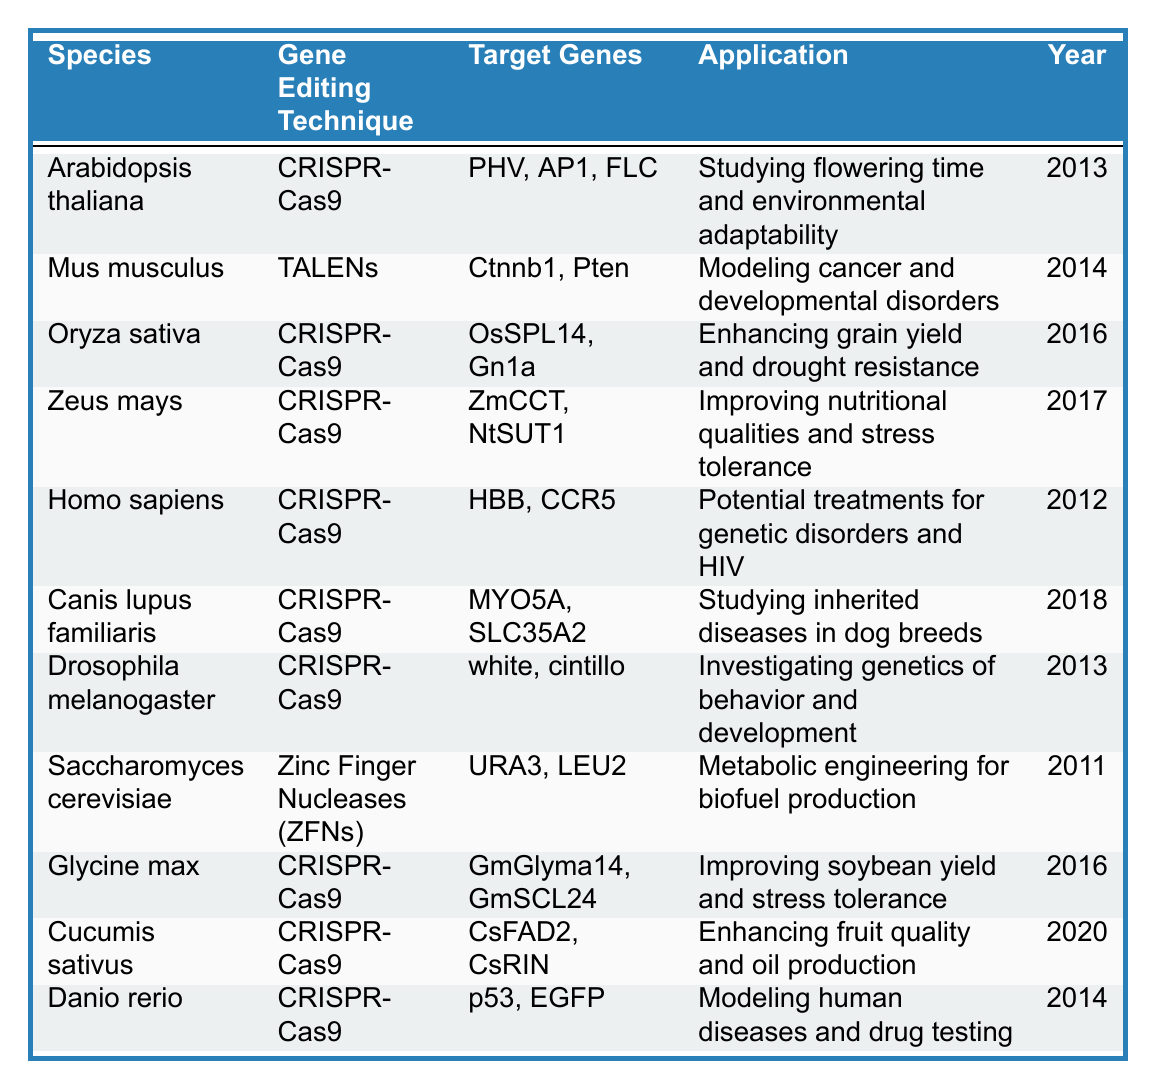What gene editing technique was first introduced for Homo sapiens? The table indicates that the gene editing technique for Homo sapiens is CRISPR-Cas9, introduced in 2012.
Answer: CRISPR-Cas9 Which species utilized TALENs for gene editing? According to the table, Mus musculus is the only species listed that utilized TALENs as a gene editing technique.
Answer: Mus musculus What are the target genes for Oryza sativa? The table shows that the target genes for Oryza sativa are OsSPL14 and Gn1a.
Answer: OsSPL14, Gn1a How many species used CRISPR-Cas9 as their gene editing technique? By counting the rows where CRISPR-Cas9 is listed, we find there are 7 species using this technique.
Answer: 7 What is the application of gene editing in Canis lupus familiaris? The table states that the application of gene editing in Canis lupus familiaris is to study inherited diseases in dog breeds.
Answer: Studying inherited diseases in dog breeds Did any species utilize Zinc Finger Nucleases before 2013? The table shows that Saccharomyces cerevisiae used Zinc Finger Nucleases (ZFNs), introduced in 2011, which is before 2013.
Answer: Yes What is the difference in the years introduced between the first and last CRISPR-Cas9 application? The first CRISPR-Cas9 application was introduced in 2012 for Homo sapiens, and the last one in 2020 for Cucumis sativus. The difference is 2020 - 2012 = 8 years.
Answer: 8 years List the target genes for the species with the latest introduction year. The latest year in the table is 2020 for Cucumis sativus, which has target genes CsFAD2 and CsRIN.
Answer: CsFAD2, CsRIN Is there any species that was introduced with CRISPR-Cas9 in the same year? Searching through the table confirms that both Arabidopsis thaliana and Drosophila melanogaster were introduced using CRISPR-Cas9 in 2013.
Answer: Yes Which species has applications related to enhancing grain yield? The table indicates that both Oryza sativa and Glycine max have applications related to enhancing grain yield.
Answer: Oryza sativa, Glycine max 